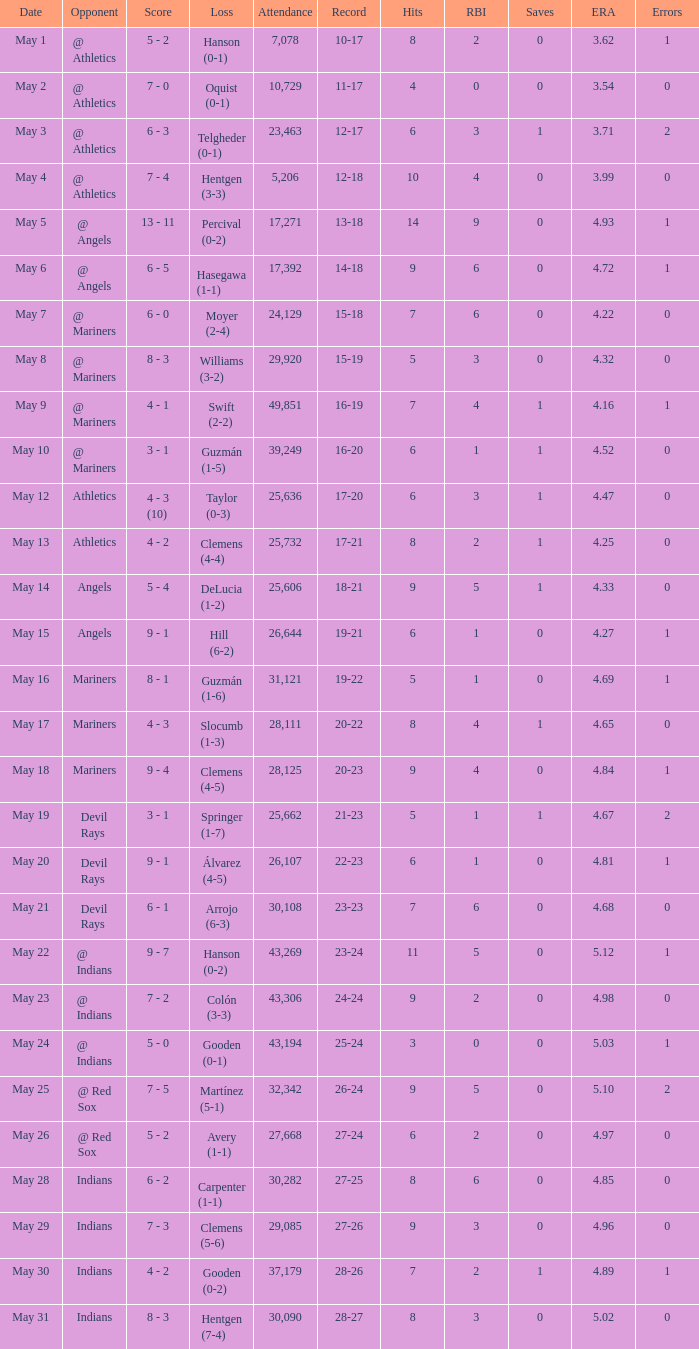When did the record of 27-25 take place? May 28. 